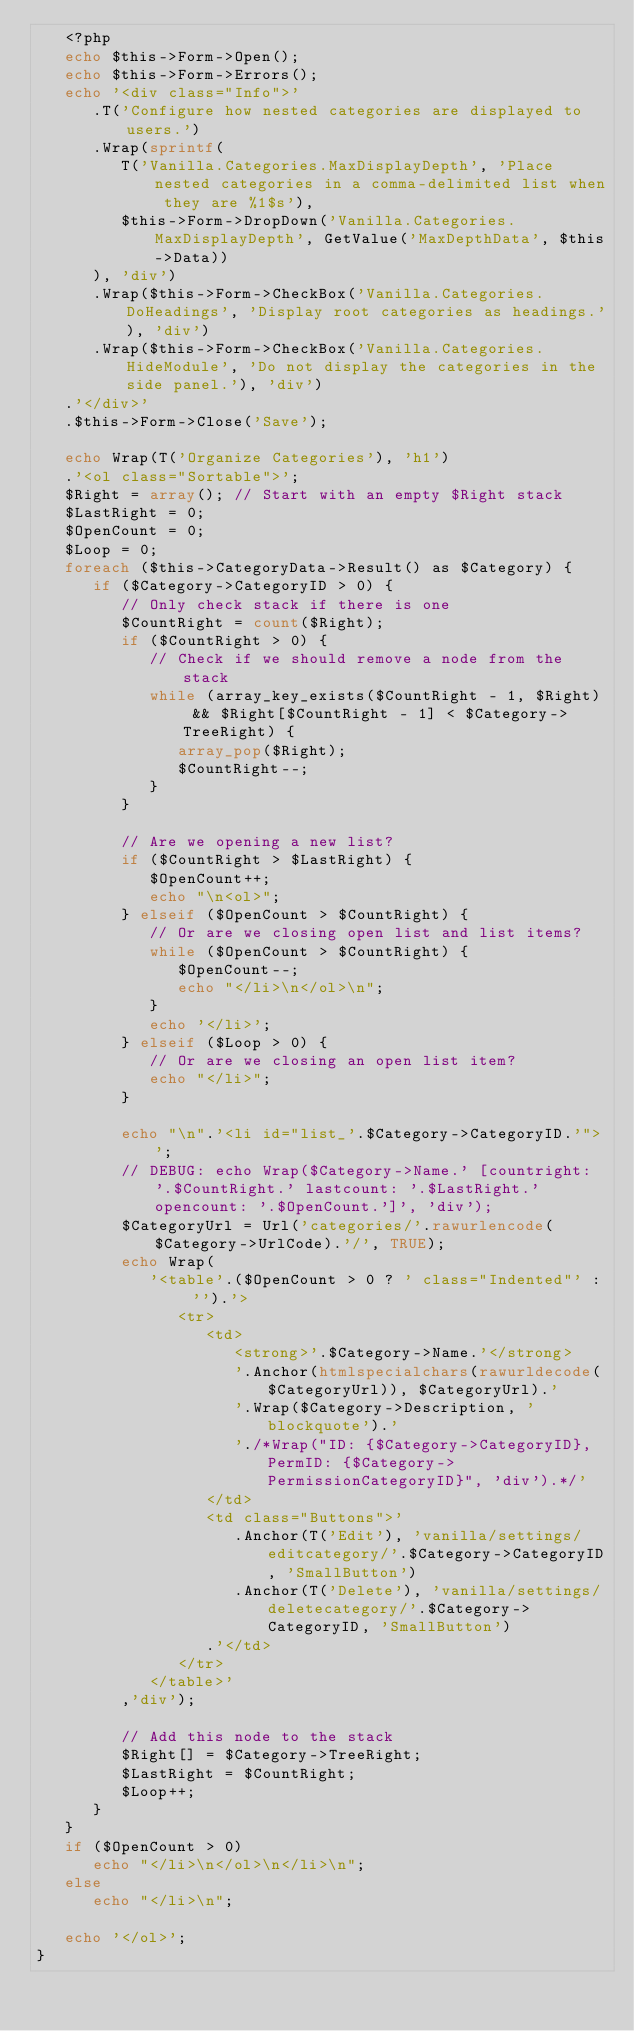<code> <loc_0><loc_0><loc_500><loc_500><_PHP_>   <?php
   echo $this->Form->Open();
   echo $this->Form->Errors();
   echo '<div class="Info">'
      .T('Configure how nested categories are displayed to users.')
      .Wrap(sprintf(
         T('Vanilla.Categories.MaxDisplayDepth', 'Place nested categories in a comma-delimited list when they are %1$s'),
         $this->Form->DropDown('Vanilla.Categories.MaxDisplayDepth', GetValue('MaxDepthData', $this->Data))
      ), 'div')
      .Wrap($this->Form->CheckBox('Vanilla.Categories.DoHeadings', 'Display root categories as headings.'), 'div')
      .Wrap($this->Form->CheckBox('Vanilla.Categories.HideModule', 'Do not display the categories in the side panel.'), 'div')
   .'</div>'
   .$this->Form->Close('Save');

   echo Wrap(T('Organize Categories'), 'h1')
   .'<ol class="Sortable">';
   $Right = array(); // Start with an empty $Right stack
   $LastRight = 0;
   $OpenCount = 0;
   $Loop = 0;
   foreach ($this->CategoryData->Result() as $Category) {
      if ($Category->CategoryID > 0) {
         // Only check stack if there is one
         $CountRight = count($Right);
         if ($CountRight > 0) {  
            // Check if we should remove a node from the stack
            while (array_key_exists($CountRight - 1, $Right) && $Right[$CountRight - 1] < $Category->TreeRight) {
               array_pop($Right);
               $CountRight--;
            }  
         }  
         
         // Are we opening a new list?
         if ($CountRight > $LastRight) {
            $OpenCount++;
            echo "\n<ol>";
         } elseif ($OpenCount > $CountRight) {
            // Or are we closing open list and list items?
            while ($OpenCount > $CountRight) {
               $OpenCount--;
               echo "</li>\n</ol>\n";
            }
            echo '</li>';
         } elseif ($Loop > 0) {
            // Or are we closing an open list item?
            echo "</li>";
         }
         
         echo "\n".'<li id="list_'.$Category->CategoryID.'">';
         // DEBUG: echo Wrap($Category->Name.' [countright: '.$CountRight.' lastcount: '.$LastRight.' opencount: '.$OpenCount.']', 'div');
         $CategoryUrl = Url('categories/'.rawurlencode($Category->UrlCode).'/', TRUE);
         echo Wrap(
            '<table'.($OpenCount > 0 ? ' class="Indented"' : '').'>
               <tr>
                  <td>
                     <strong>'.$Category->Name.'</strong>
                     '.Anchor(htmlspecialchars(rawurldecode($CategoryUrl)), $CategoryUrl).'
                     '.Wrap($Category->Description, 'blockquote').'
                     './*Wrap("ID: {$Category->CategoryID}, PermID: {$Category->PermissionCategoryID}", 'div').*/'
                  </td>
                  <td class="Buttons">'
                     .Anchor(T('Edit'), 'vanilla/settings/editcategory/'.$Category->CategoryID, 'SmallButton')
                     .Anchor(T('Delete'), 'vanilla/settings/deletecategory/'.$Category->CategoryID, 'SmallButton')
                  .'</td>
               </tr>
            </table>'
         ,'div');
         
         // Add this node to the stack  
         $Right[] = $Category->TreeRight;
         $LastRight = $CountRight;
         $Loop++;
      }
   }
   if ($OpenCount > 0)
      echo "</li>\n</ol>\n</li>\n";
   else
      echo "</li>\n";
      
   echo '</ol>';
}</code> 